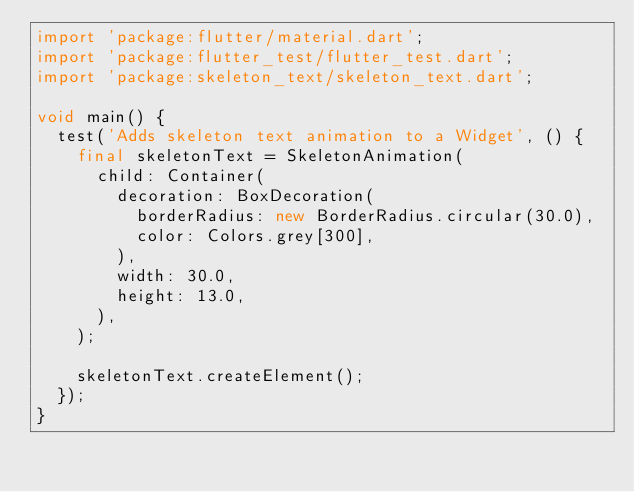Convert code to text. <code><loc_0><loc_0><loc_500><loc_500><_Dart_>import 'package:flutter/material.dart';
import 'package:flutter_test/flutter_test.dart';
import 'package:skeleton_text/skeleton_text.dart';

void main() {
  test('Adds skeleton text animation to a Widget', () {
    final skeletonText = SkeletonAnimation(
      child: Container(
        decoration: BoxDecoration(
          borderRadius: new BorderRadius.circular(30.0),
          color: Colors.grey[300],
        ),
        width: 30.0,
        height: 13.0,
      ),
    );

    skeletonText.createElement();
  });
}
</code> 